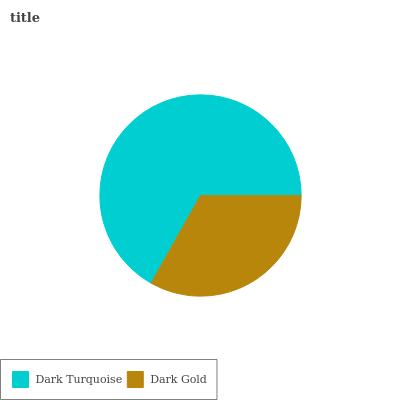Is Dark Gold the minimum?
Answer yes or no. Yes. Is Dark Turquoise the maximum?
Answer yes or no. Yes. Is Dark Gold the maximum?
Answer yes or no. No. Is Dark Turquoise greater than Dark Gold?
Answer yes or no. Yes. Is Dark Gold less than Dark Turquoise?
Answer yes or no. Yes. Is Dark Gold greater than Dark Turquoise?
Answer yes or no. No. Is Dark Turquoise less than Dark Gold?
Answer yes or no. No. Is Dark Turquoise the high median?
Answer yes or no. Yes. Is Dark Gold the low median?
Answer yes or no. Yes. Is Dark Gold the high median?
Answer yes or no. No. Is Dark Turquoise the low median?
Answer yes or no. No. 